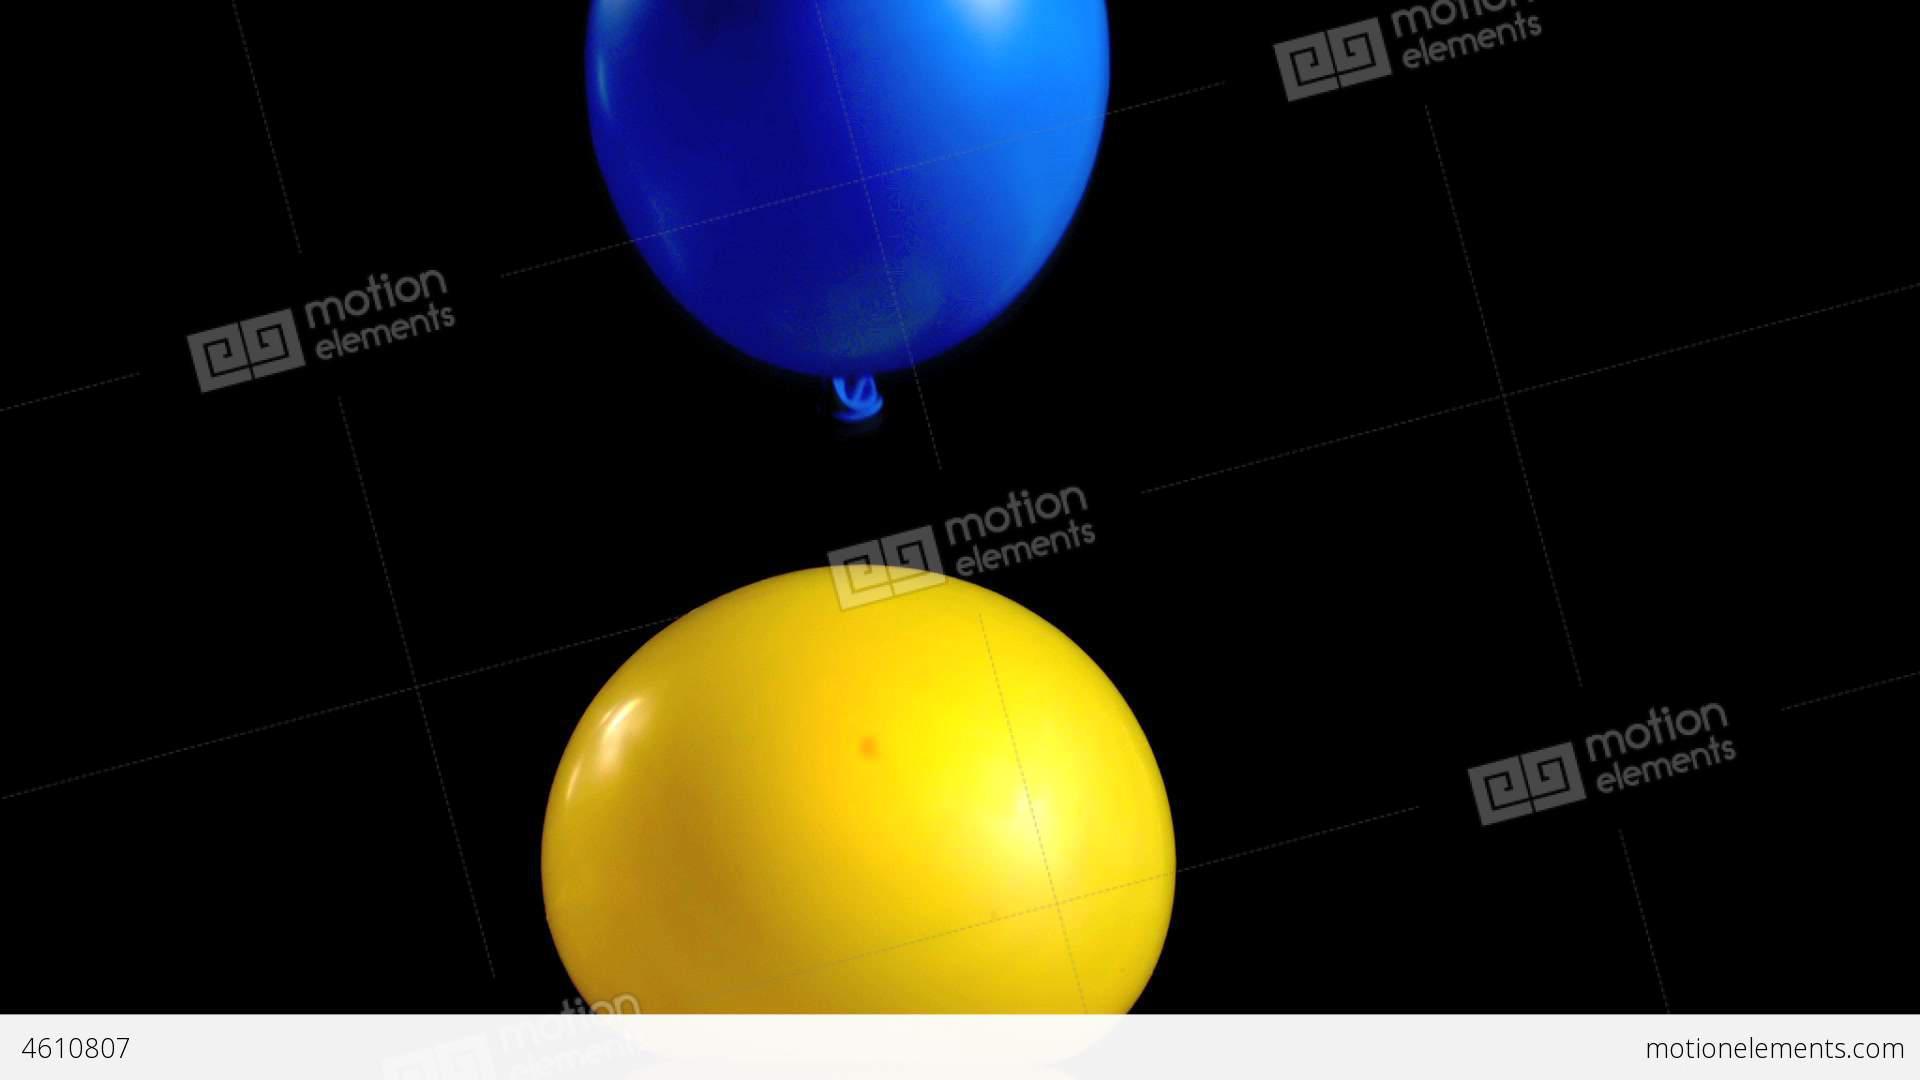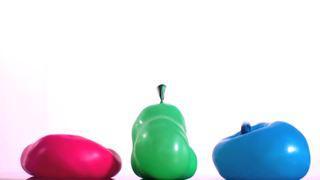The first image is the image on the left, the second image is the image on the right. Analyze the images presented: Is the assertion "One of the balloons is bright pink." valid? Answer yes or no. Yes. The first image is the image on the left, the second image is the image on the right. Examine the images to the left and right. Is the description "One image includes a lumpy-looking green balloon, and the other image includes at least two balloons of different colors." accurate? Answer yes or no. Yes. 